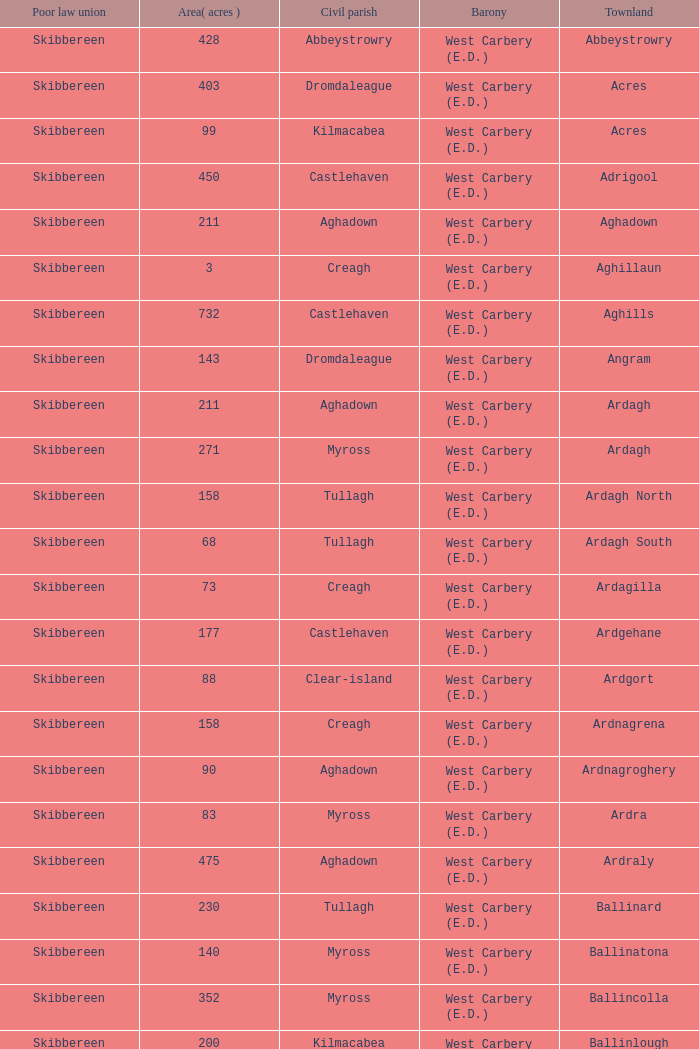What are the Baronies when the area (in acres) is 276? West Carbery (E.D.). 